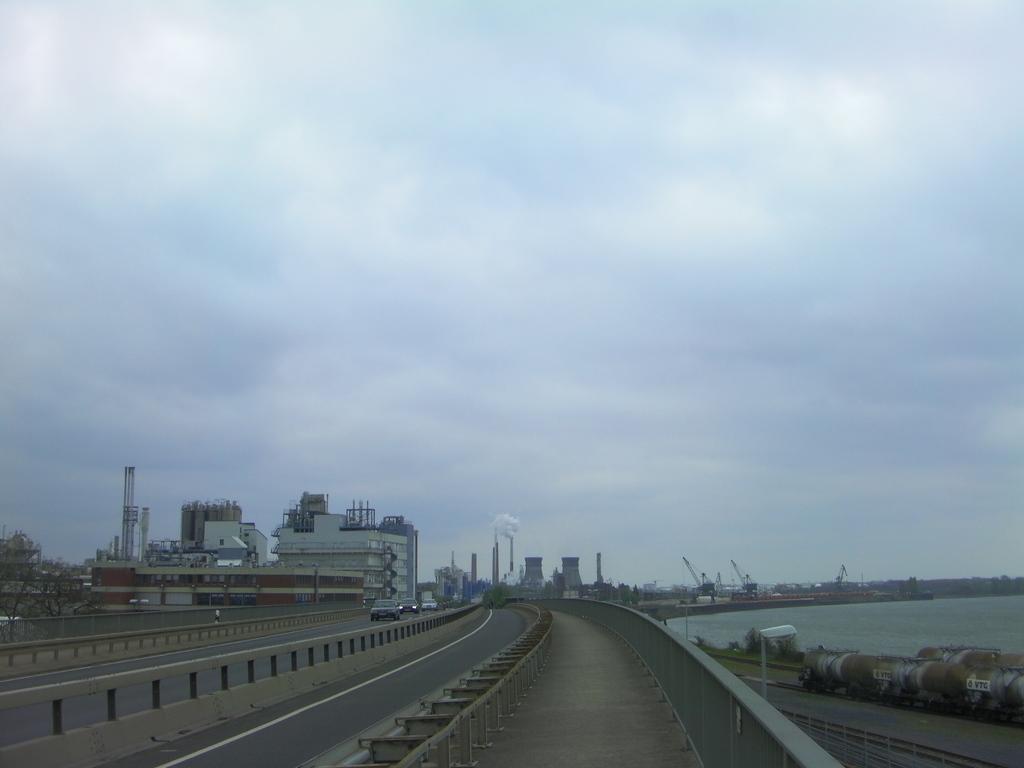In one or two sentences, can you explain what this image depicts? In this image I can see few roads in the front and in the center I can see few vehicles on the road. On the right side of this image I can see few poles, a light and the water. On the left side of this image I can see few buildings and few trees. In the background I can see few chimney towers, clouds and the sky. 